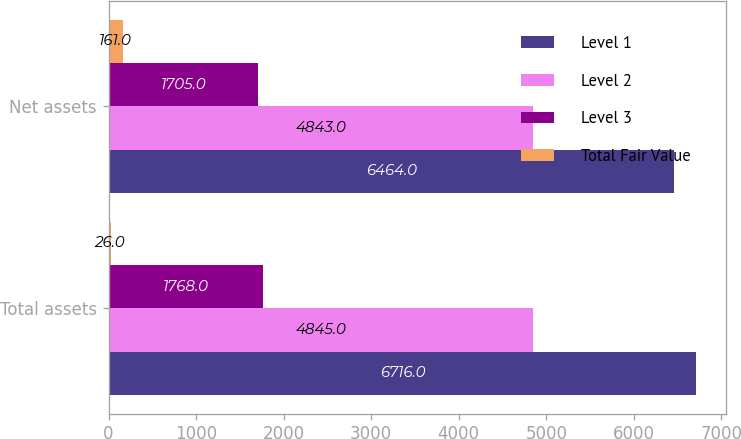<chart> <loc_0><loc_0><loc_500><loc_500><stacked_bar_chart><ecel><fcel>Total assets<fcel>Net assets<nl><fcel>Level 1<fcel>6716<fcel>6464<nl><fcel>Level 2<fcel>4845<fcel>4843<nl><fcel>Level 3<fcel>1768<fcel>1705<nl><fcel>Total Fair Value<fcel>26<fcel>161<nl></chart> 